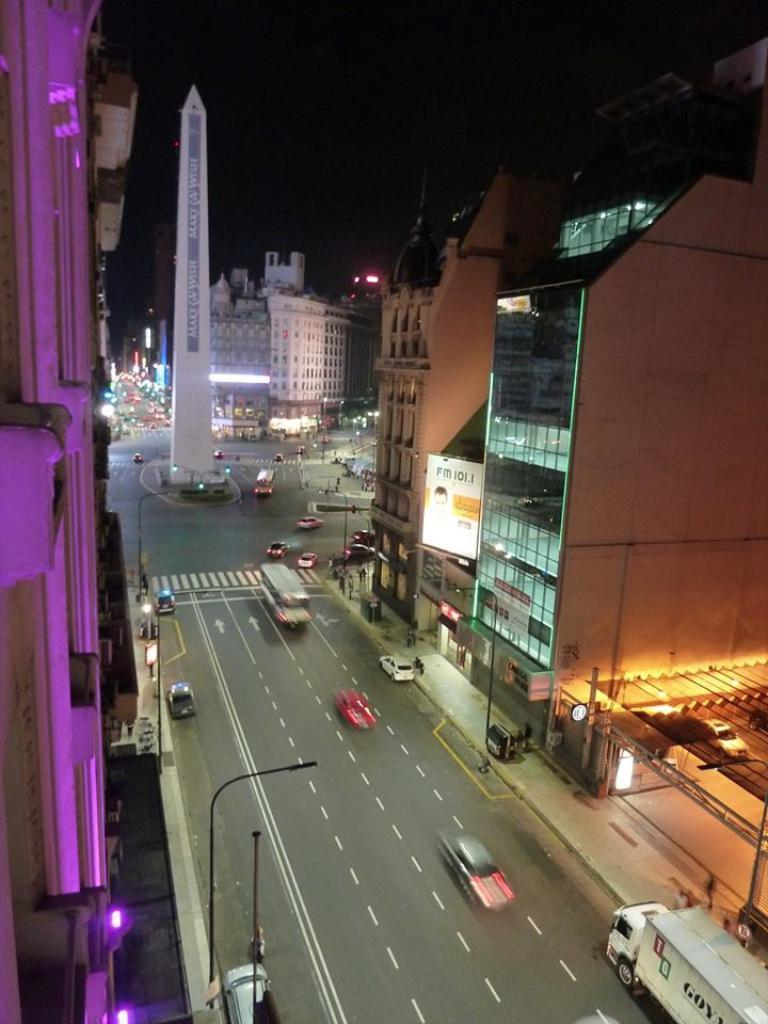What is the main feature of the image? There is a road in the image. What is happening on the road? There are vehicles on the road. What else can be seen in the image besides the road and vehicles? There are buildings visible in the image. What type of pancake is being served at the restaurant in the image? There is no restaurant or pancake present in the image; it features a road with vehicles and buildings. 